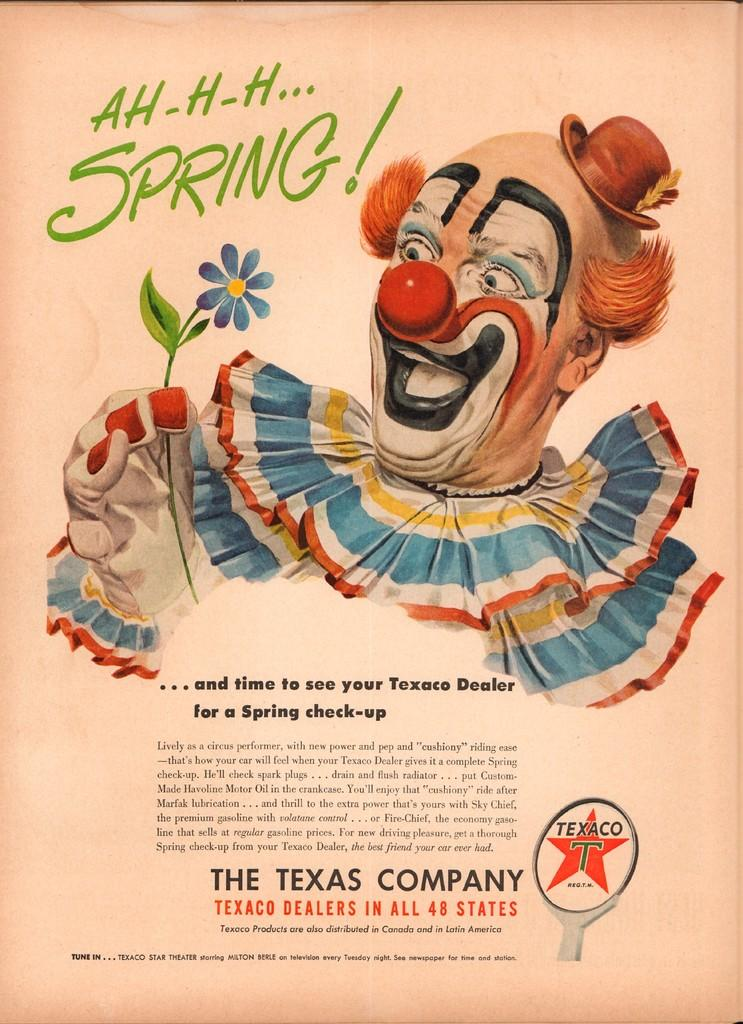What is the main subject in the center of the image? There is a clown in the center of the image. What is the clown holding in the image? The clown is holding a flower. Is there any text present in the image? Yes, there is text written on the image. Where is the throne located in the image? There is no throne present in the image. What type of flesh can be seen on the clown's face in the image? The image does not show any flesh on the clown's face, as it is a clown dressed in costume. 